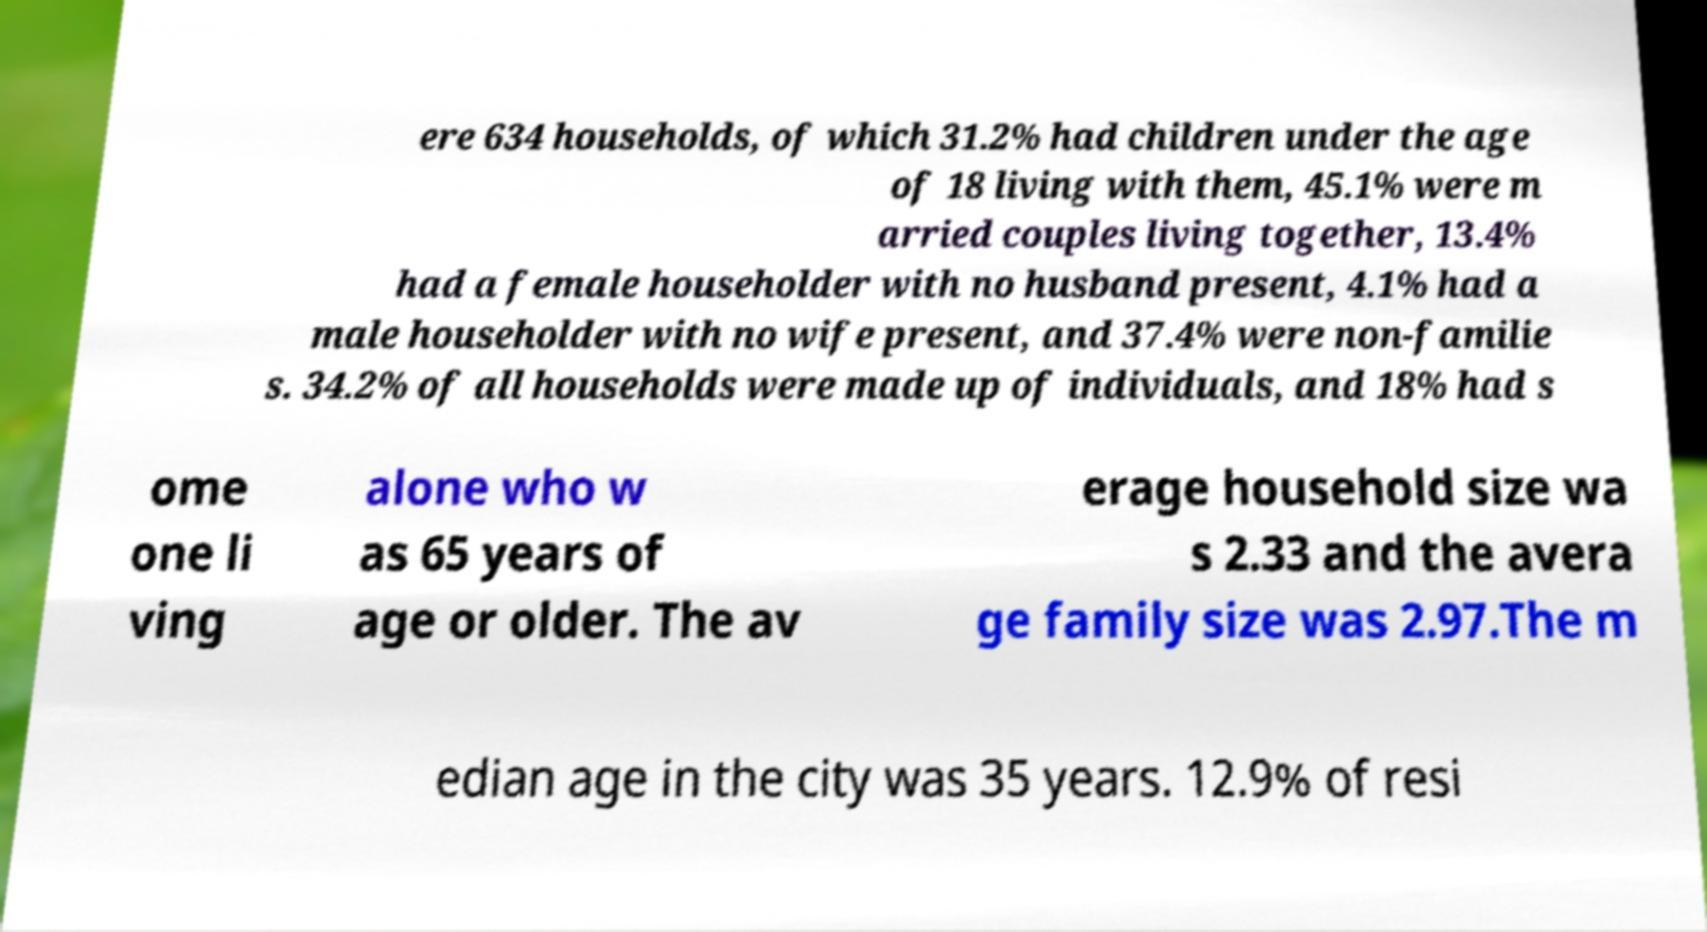There's text embedded in this image that I need extracted. Can you transcribe it verbatim? ere 634 households, of which 31.2% had children under the age of 18 living with them, 45.1% were m arried couples living together, 13.4% had a female householder with no husband present, 4.1% had a male householder with no wife present, and 37.4% were non-familie s. 34.2% of all households were made up of individuals, and 18% had s ome one li ving alone who w as 65 years of age or older. The av erage household size wa s 2.33 and the avera ge family size was 2.97.The m edian age in the city was 35 years. 12.9% of resi 